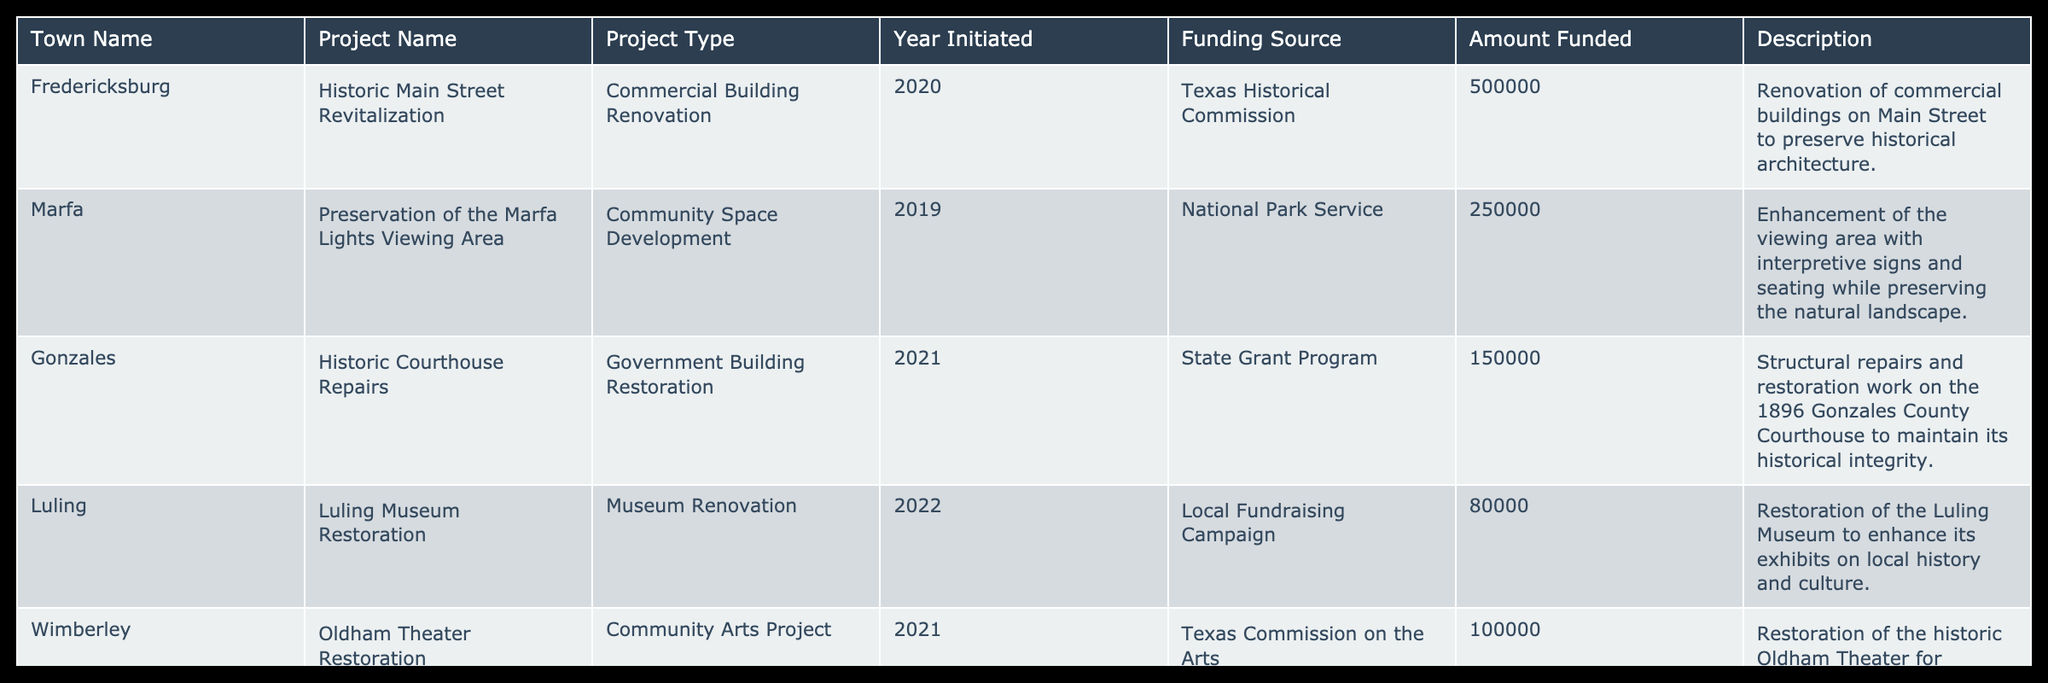What is the total funding amount for the projects listed in the table? To find the total funding amount, I will sum the "Amount Funded" column of all the projects. The amounts are 500000, 250000, 150000, 80000, 100000, 300000, and 200000. Adding these values gives: 500000 + 250000 + 150000 + 80000 + 100000 + 300000 + 200000 = 1380000.
Answer: 1380000 Which town has the highest funding for a preservation project? Comparing the "Amount Funded" for each town: Fredericksburg has 500000, Marfa has 250000, Gonzales has 150000, Luling has 80000, Wimberley has 100000, Palestine has 300000, and Nacogdoches has 200000. Fredericksburg with 500000 has the highest funding.
Answer: Fredericksburg Is there a project initiated in the year 2022? Reviewing the "Year Initiated" column to see if 2022 is listed. Only Luling's project, the museum restoration, was initiated in 2022. Therefore, there is indeed a project from that year.
Answer: Yes What type of project was funded with 200000? Looking through the "Amount Funded" column, the only project funded with 200000 is the Heritage Square Revitalization in Nacogdoches. According to the "Project Type" column, it is a public space development project.
Answer: Public Space Development How many projects in the table relate to building restoration? I will check the "Project Type" column for any entries that mention building restoration. There are three projects listed that fit this category: Historic Courthouse Repairs in Gonzales, which is a government building restoration, and both the historic depot renovation and the old theater restoration, which can also be classified under the broad restoration category as they are restoring buildings. Therefore, there are three such projects.
Answer: 3 What was the funding source for the Oldham Theater Restoration? Referring to the "Funding Source" column for the Oldham Theater Restoration project in Wimberley, it is noted that the funding source is the Texas Commission on the Arts.
Answer: Texas Commission on the Arts In what year did the Preservation of the Marfa Lights Viewing Area project begin? Checking the "Year Initiated" column for the Marfa project, it clearly states that the project was initiated in 2019.
Answer: 2019 Are there any projects funded by a local fundraising campaign? Reviewing the "Funding Source" column, Luling's Museum Restoration project is noted to be funded by a local fundraising campaign. Thus, there is at least one project that meets this criteria.
Answer: Yes 